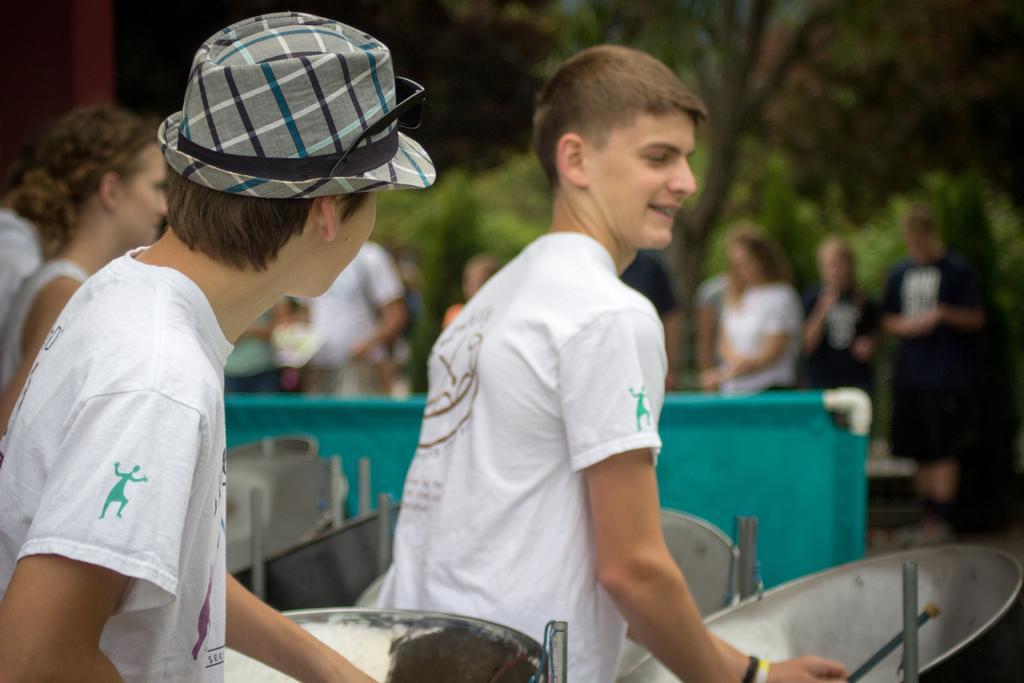How would you summarize this image in a sentence or two? In the middle of the image few people are standing and holding some musical instruments. Beside them there is fencing. Behind the fencing few people are standing and watching. Behind them there are some trees. 